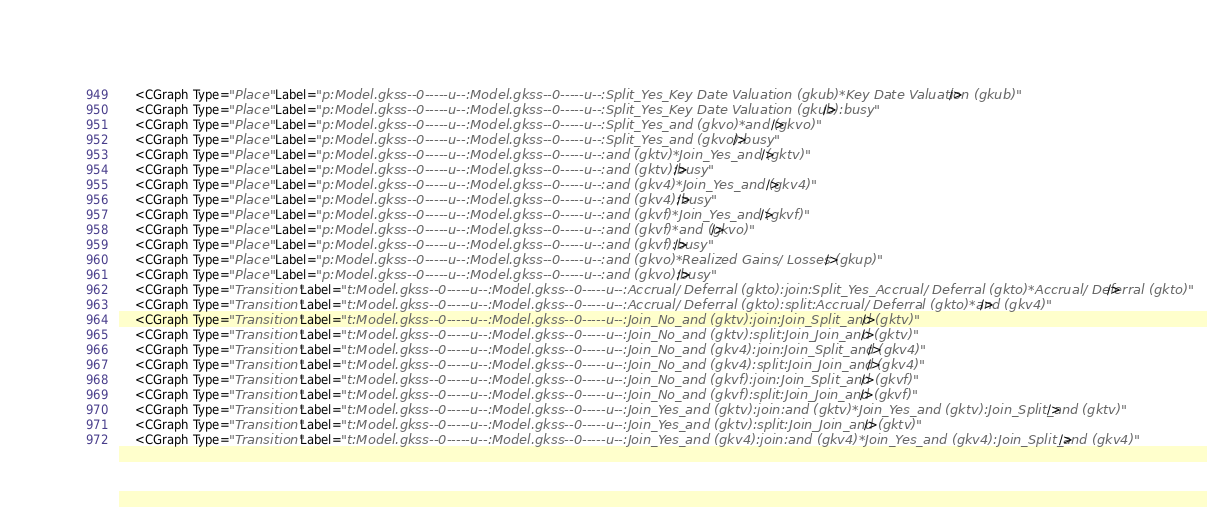<code> <loc_0><loc_0><loc_500><loc_500><_XML_>    <CGraph Type="Place" Label="p:Model.gkss--0-----u--:Model.gkss--0-----u--:Split_Yes_Key Date Valuation (gkub)*Key Date Valuation (gkub)"/>
    <CGraph Type="Place" Label="p:Model.gkss--0-----u--:Model.gkss--0-----u--:Split_Yes_Key Date Valuation (gkub):busy"/>
    <CGraph Type="Place" Label="p:Model.gkss--0-----u--:Model.gkss--0-----u--:Split_Yes_and (gkvo)*and (gkvo)"/>
    <CGraph Type="Place" Label="p:Model.gkss--0-----u--:Model.gkss--0-----u--:Split_Yes_and (gkvo):busy"/>
    <CGraph Type="Place" Label="p:Model.gkss--0-----u--:Model.gkss--0-----u--:and (gktv)*Join_Yes_and (gktv)"/>
    <CGraph Type="Place" Label="p:Model.gkss--0-----u--:Model.gkss--0-----u--:and (gktv):busy"/>
    <CGraph Type="Place" Label="p:Model.gkss--0-----u--:Model.gkss--0-----u--:and (gkv4)*Join_Yes_and (gkv4)"/>
    <CGraph Type="Place" Label="p:Model.gkss--0-----u--:Model.gkss--0-----u--:and (gkv4):busy"/>
    <CGraph Type="Place" Label="p:Model.gkss--0-----u--:Model.gkss--0-----u--:and (gkvf)*Join_Yes_and (gkvf)"/>
    <CGraph Type="Place" Label="p:Model.gkss--0-----u--:Model.gkss--0-----u--:and (gkvf)*and (gkvo)"/>
    <CGraph Type="Place" Label="p:Model.gkss--0-----u--:Model.gkss--0-----u--:and (gkvf):busy"/>
    <CGraph Type="Place" Label="p:Model.gkss--0-----u--:Model.gkss--0-----u--:and (gkvo)*Realized Gains/ Losses (gkup)"/>
    <CGraph Type="Place" Label="p:Model.gkss--0-----u--:Model.gkss--0-----u--:and (gkvo):busy"/>
    <CGraph Type="Transition" Label="t:Model.gkss--0-----u--:Model.gkss--0-----u--:Accrual/ Deferral (gkto):join:Split_Yes_Accrual/ Deferral (gkto)*Accrual/ Deferral (gkto)"/>
    <CGraph Type="Transition" Label="t:Model.gkss--0-----u--:Model.gkss--0-----u--:Accrual/ Deferral (gkto):split:Accrual/ Deferral (gkto)*and (gkv4)"/>
    <CGraph Type="Transition" Label="t:Model.gkss--0-----u--:Model.gkss--0-----u--:Join_No_and (gktv):join:Join_Split_and (gktv)"/>
    <CGraph Type="Transition" Label="t:Model.gkss--0-----u--:Model.gkss--0-----u--:Join_No_and (gktv):split:Join_Join_and (gktv)"/>
    <CGraph Type="Transition" Label="t:Model.gkss--0-----u--:Model.gkss--0-----u--:Join_No_and (gkv4):join:Join_Split_and (gkv4)"/>
    <CGraph Type="Transition" Label="t:Model.gkss--0-----u--:Model.gkss--0-----u--:Join_No_and (gkv4):split:Join_Join_and (gkv4)"/>
    <CGraph Type="Transition" Label="t:Model.gkss--0-----u--:Model.gkss--0-----u--:Join_No_and (gkvf):join:Join_Split_and (gkvf)"/>
    <CGraph Type="Transition" Label="t:Model.gkss--0-----u--:Model.gkss--0-----u--:Join_No_and (gkvf):split:Join_Join_and (gkvf)"/>
    <CGraph Type="Transition" Label="t:Model.gkss--0-----u--:Model.gkss--0-----u--:Join_Yes_and (gktv):join:and (gktv)*Join_Yes_and (gktv):Join_Split_and (gktv)"/>
    <CGraph Type="Transition" Label="t:Model.gkss--0-----u--:Model.gkss--0-----u--:Join_Yes_and (gktv):split:Join_Join_and (gktv)"/>
    <CGraph Type="Transition" Label="t:Model.gkss--0-----u--:Model.gkss--0-----u--:Join_Yes_and (gkv4):join:and (gkv4)*Join_Yes_and (gkv4):Join_Split_and (gkv4)"/></code> 